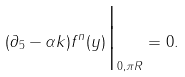Convert formula to latex. <formula><loc_0><loc_0><loc_500><loc_500>( \partial _ { 5 } - \alpha k ) f ^ { n } ( y ) \Big | _ { 0 , \pi R } = 0 .</formula> 